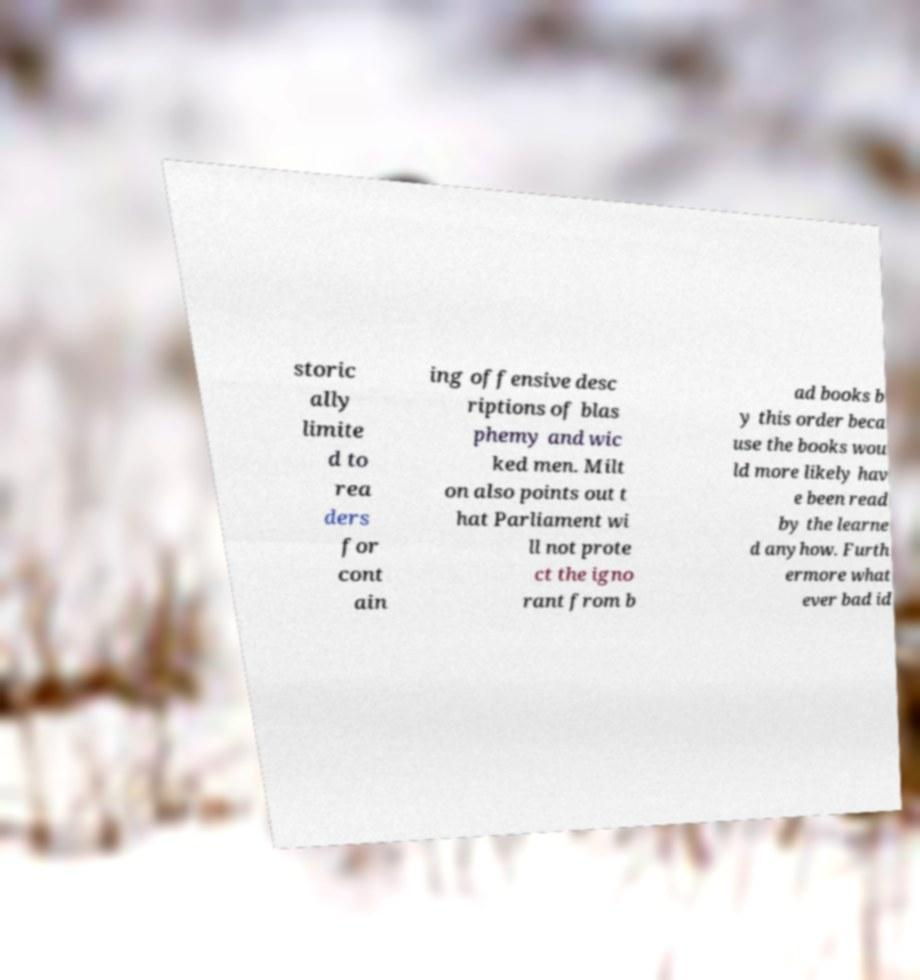Please identify and transcribe the text found in this image. storic ally limite d to rea ders for cont ain ing offensive desc riptions of blas phemy and wic ked men. Milt on also points out t hat Parliament wi ll not prote ct the igno rant from b ad books b y this order beca use the books wou ld more likely hav e been read by the learne d anyhow. Furth ermore what ever bad id 